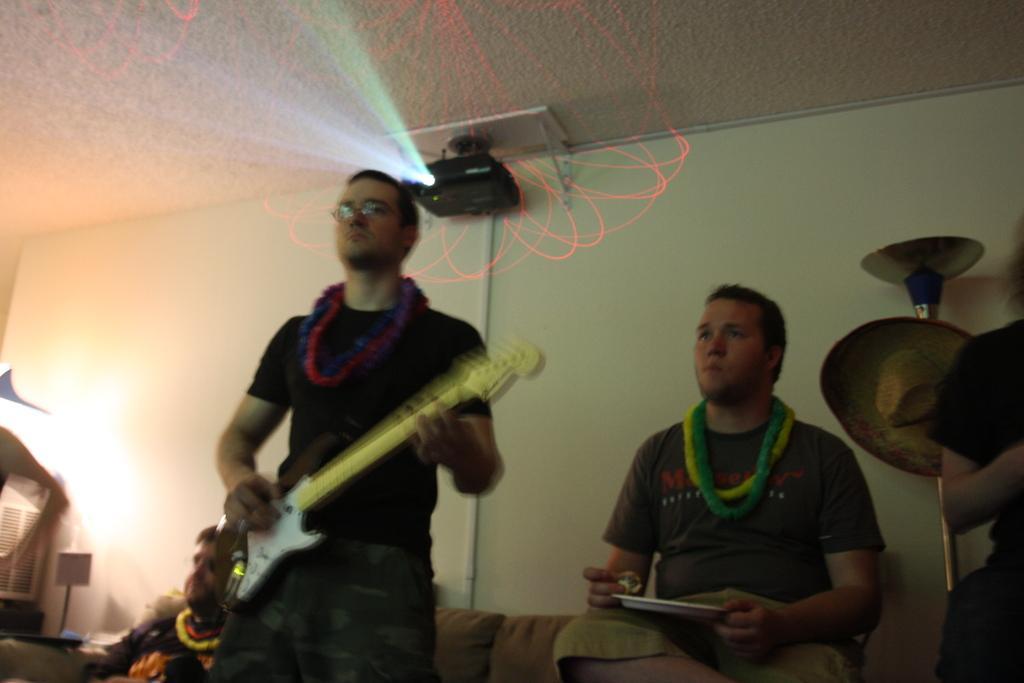How would you summarize this image in a sentence or two? In this image I can see number of people. I can see one man is playing guitar. In the background I can see a projector. 